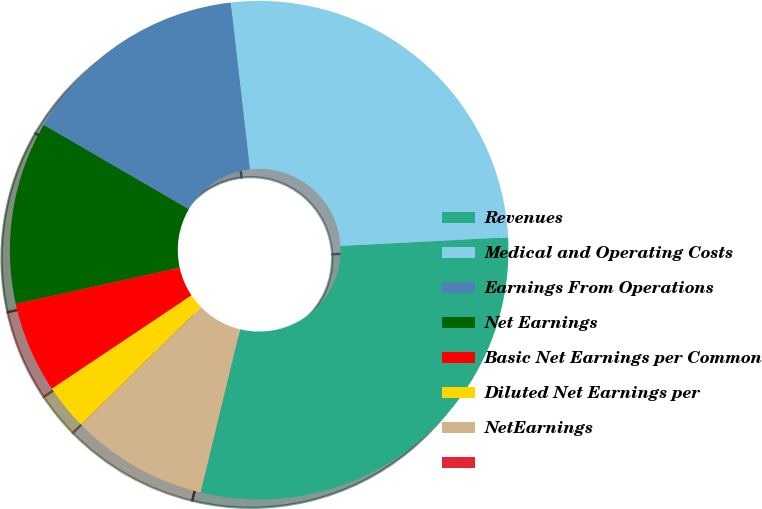<chart> <loc_0><loc_0><loc_500><loc_500><pie_chart><fcel>Revenues<fcel>Medical and Operating Costs<fcel>Earnings From Operations<fcel>Net Earnings<fcel>Basic Net Earnings per Common<fcel>Diluted Net Earnings per<fcel>NetEarnings<fcel>Unnamed: 7<nl><fcel>29.6%<fcel>26.0%<fcel>14.8%<fcel>11.84%<fcel>5.92%<fcel>2.96%<fcel>8.88%<fcel>0.0%<nl></chart> 